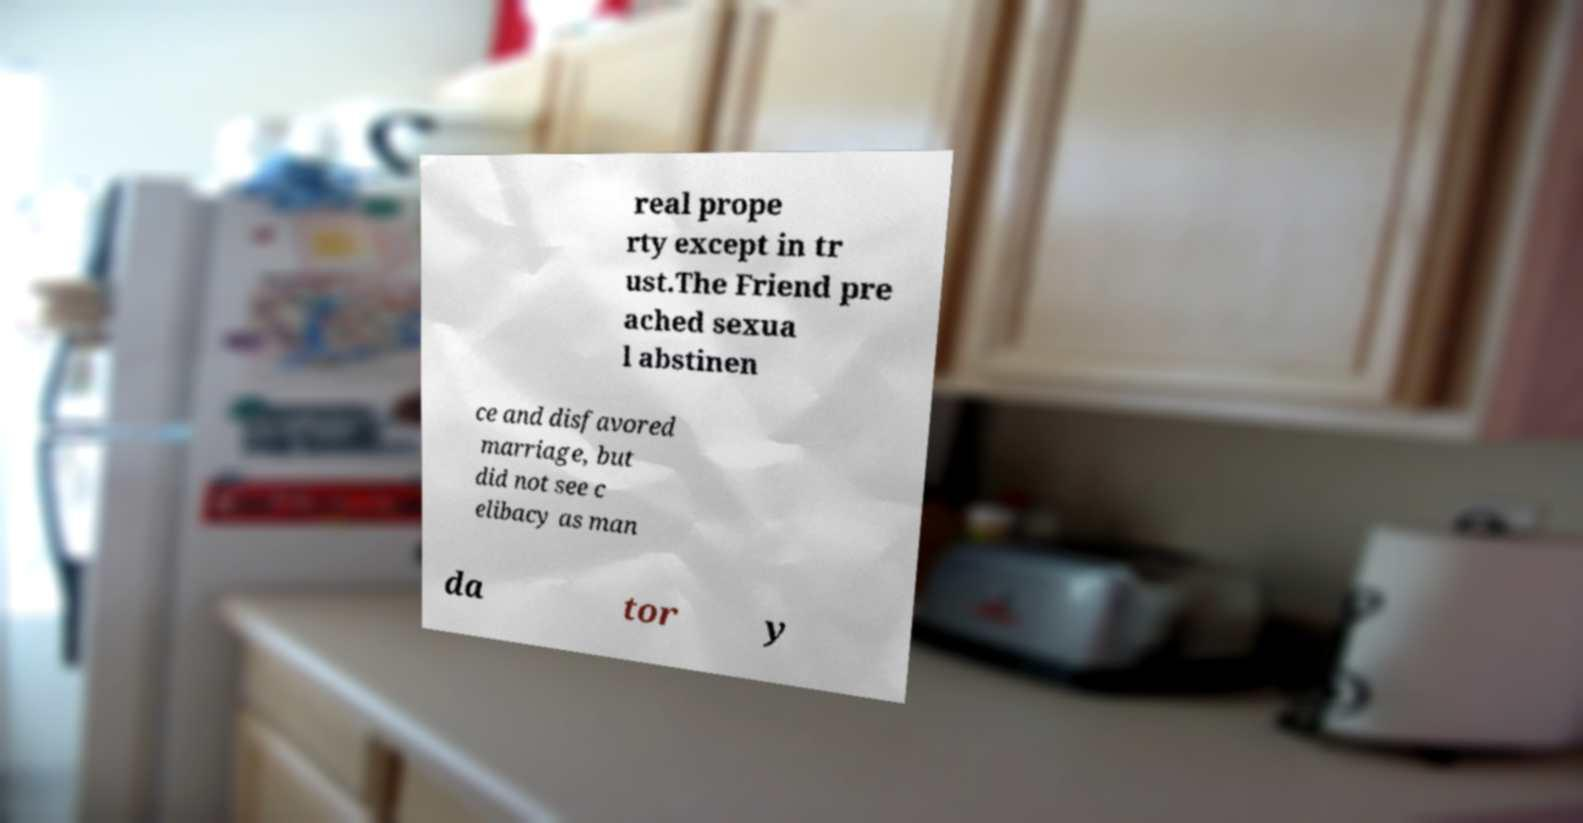Can you accurately transcribe the text from the provided image for me? real prope rty except in tr ust.The Friend pre ached sexua l abstinen ce and disfavored marriage, but did not see c elibacy as man da tor y 